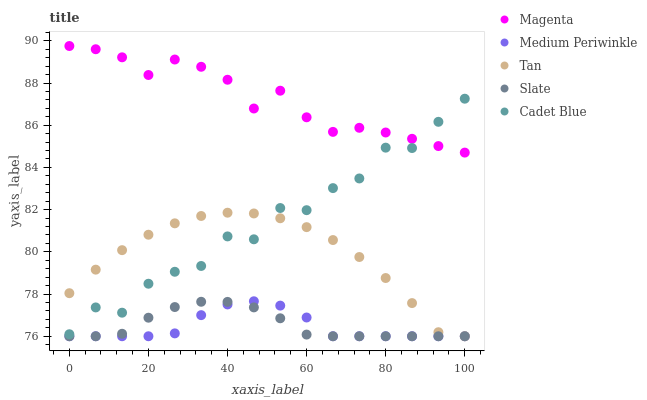Does Medium Periwinkle have the minimum area under the curve?
Answer yes or no. Yes. Does Magenta have the maximum area under the curve?
Answer yes or no. Yes. Does Slate have the minimum area under the curve?
Answer yes or no. No. Does Slate have the maximum area under the curve?
Answer yes or no. No. Is Slate the smoothest?
Answer yes or no. Yes. Is Cadet Blue the roughest?
Answer yes or no. Yes. Is Magenta the smoothest?
Answer yes or no. No. Is Magenta the roughest?
Answer yes or no. No. Does Slate have the lowest value?
Answer yes or no. Yes. Does Magenta have the lowest value?
Answer yes or no. No. Does Magenta have the highest value?
Answer yes or no. Yes. Does Slate have the highest value?
Answer yes or no. No. Is Medium Periwinkle less than Cadet Blue?
Answer yes or no. Yes. Is Magenta greater than Tan?
Answer yes or no. Yes. Does Medium Periwinkle intersect Tan?
Answer yes or no. Yes. Is Medium Periwinkle less than Tan?
Answer yes or no. No. Is Medium Periwinkle greater than Tan?
Answer yes or no. No. Does Medium Periwinkle intersect Cadet Blue?
Answer yes or no. No. 